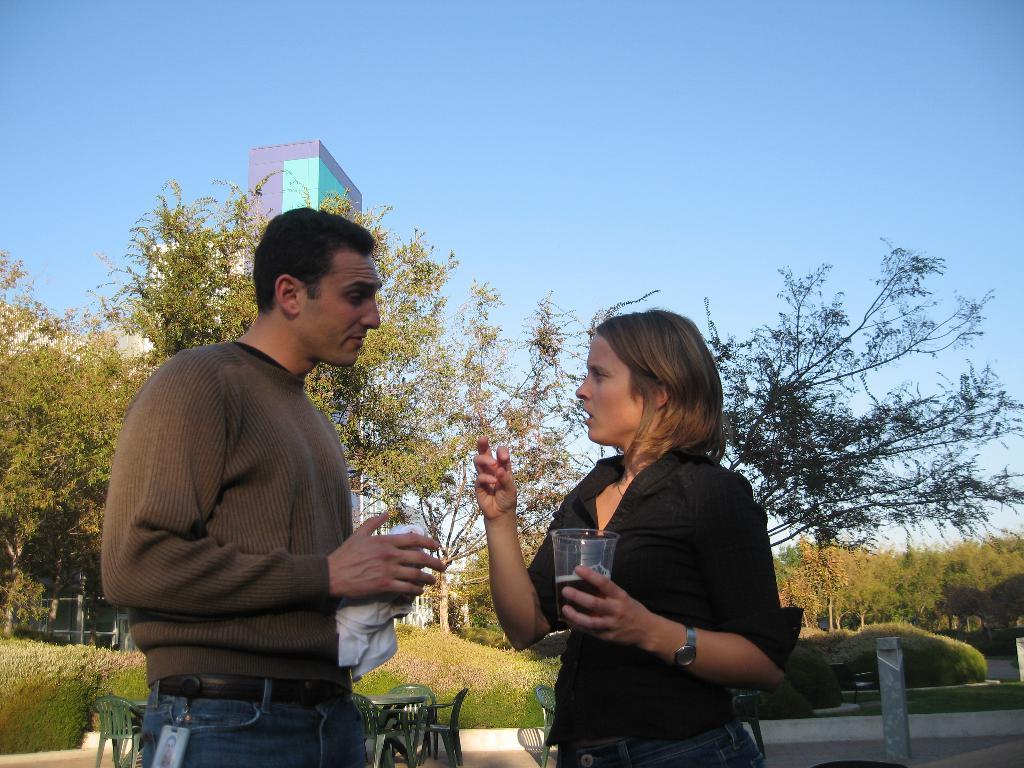Describe this image in one or two sentences. On the left side, there is a person in a shirt, holding an object, standing and speaking. On the right side, there is a woman in black color shirt, holding a glass filled with drink, smiling and speaking. In the background, there are chairs and a table arranged on the floor, there are trees, plants, a building and there is a blue sky. 